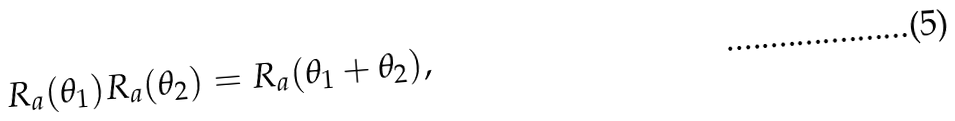<formula> <loc_0><loc_0><loc_500><loc_500>R _ { a } ( \theta _ { 1 } ) R _ { a } ( \theta _ { 2 } ) = R _ { a } ( \theta _ { 1 } + \theta _ { 2 } ) ,</formula> 